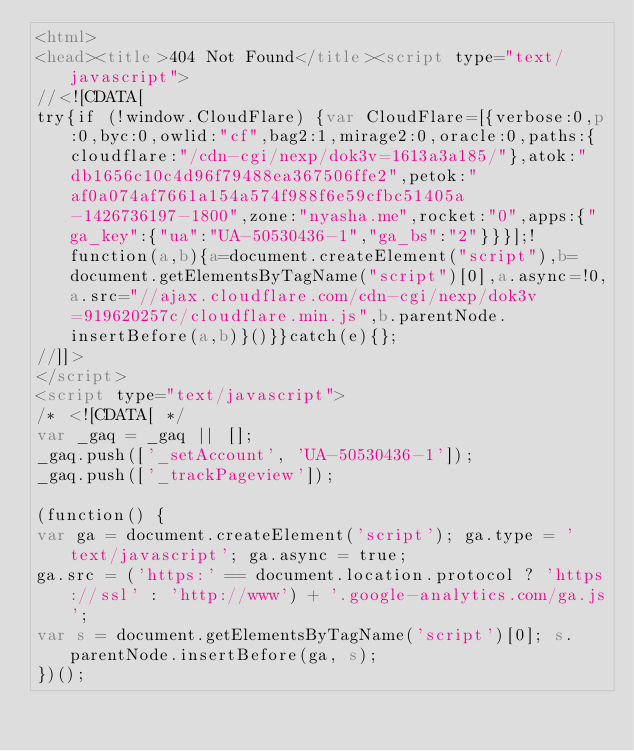Convert code to text. <code><loc_0><loc_0><loc_500><loc_500><_HTML_><html>
<head><title>404 Not Found</title><script type="text/javascript">
//<![CDATA[
try{if (!window.CloudFlare) {var CloudFlare=[{verbose:0,p:0,byc:0,owlid:"cf",bag2:1,mirage2:0,oracle:0,paths:{cloudflare:"/cdn-cgi/nexp/dok3v=1613a3a185/"},atok:"db1656c10c4d96f79488ea367506ffe2",petok:"af0a074af7661a154a574f988f6e59cfbc51405a-1426736197-1800",zone:"nyasha.me",rocket:"0",apps:{"ga_key":{"ua":"UA-50530436-1","ga_bs":"2"}}}];!function(a,b){a=document.createElement("script"),b=document.getElementsByTagName("script")[0],a.async=!0,a.src="//ajax.cloudflare.com/cdn-cgi/nexp/dok3v=919620257c/cloudflare.min.js",b.parentNode.insertBefore(a,b)}()}}catch(e){};
//]]>
</script>
<script type="text/javascript">
/* <![CDATA[ */
var _gaq = _gaq || [];
_gaq.push(['_setAccount', 'UA-50530436-1']);
_gaq.push(['_trackPageview']);

(function() {
var ga = document.createElement('script'); ga.type = 'text/javascript'; ga.async = true;
ga.src = ('https:' == document.location.protocol ? 'https://ssl' : 'http://www') + '.google-analytics.com/ga.js';
var s = document.getElementsByTagName('script')[0]; s.parentNode.insertBefore(ga, s);
})();
</code> 